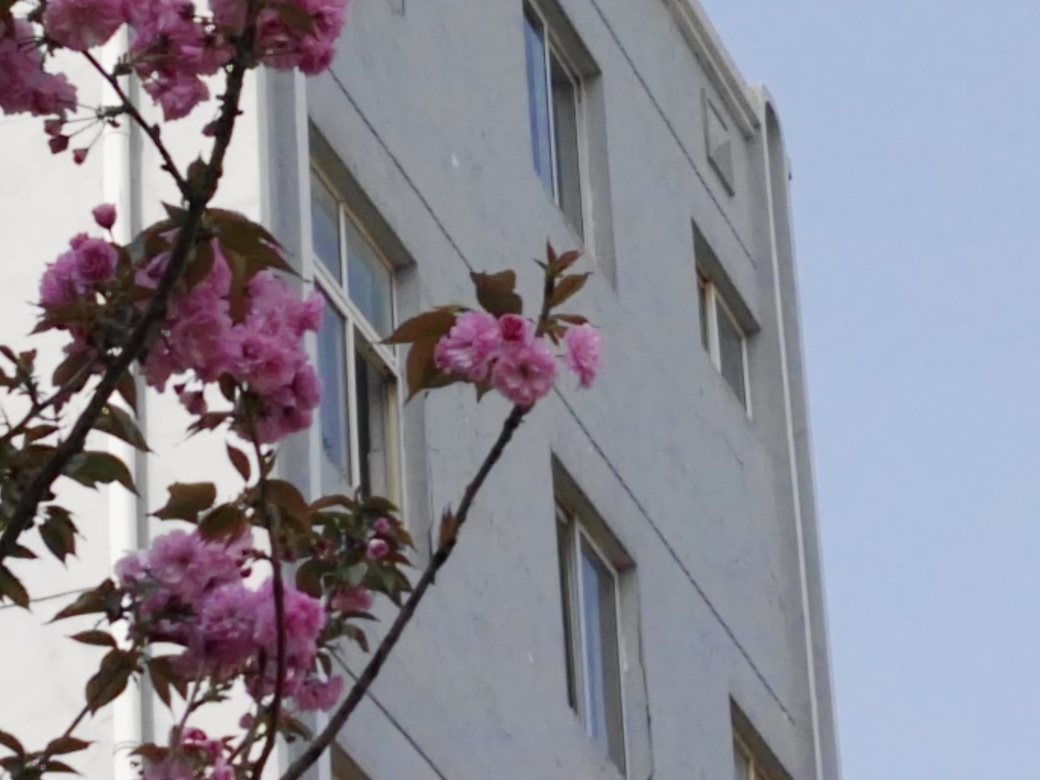What can you infer from the architectural style of the building? The building in the image appears to have a simple, utilitarian design often found in mid-20th-century architecture. It's characterized by its clean lines, lack of ornamental details, and functional appearance. This style is commonly associated with apartment buildings that focus on providing basic accommodation without extraneous design elements. 